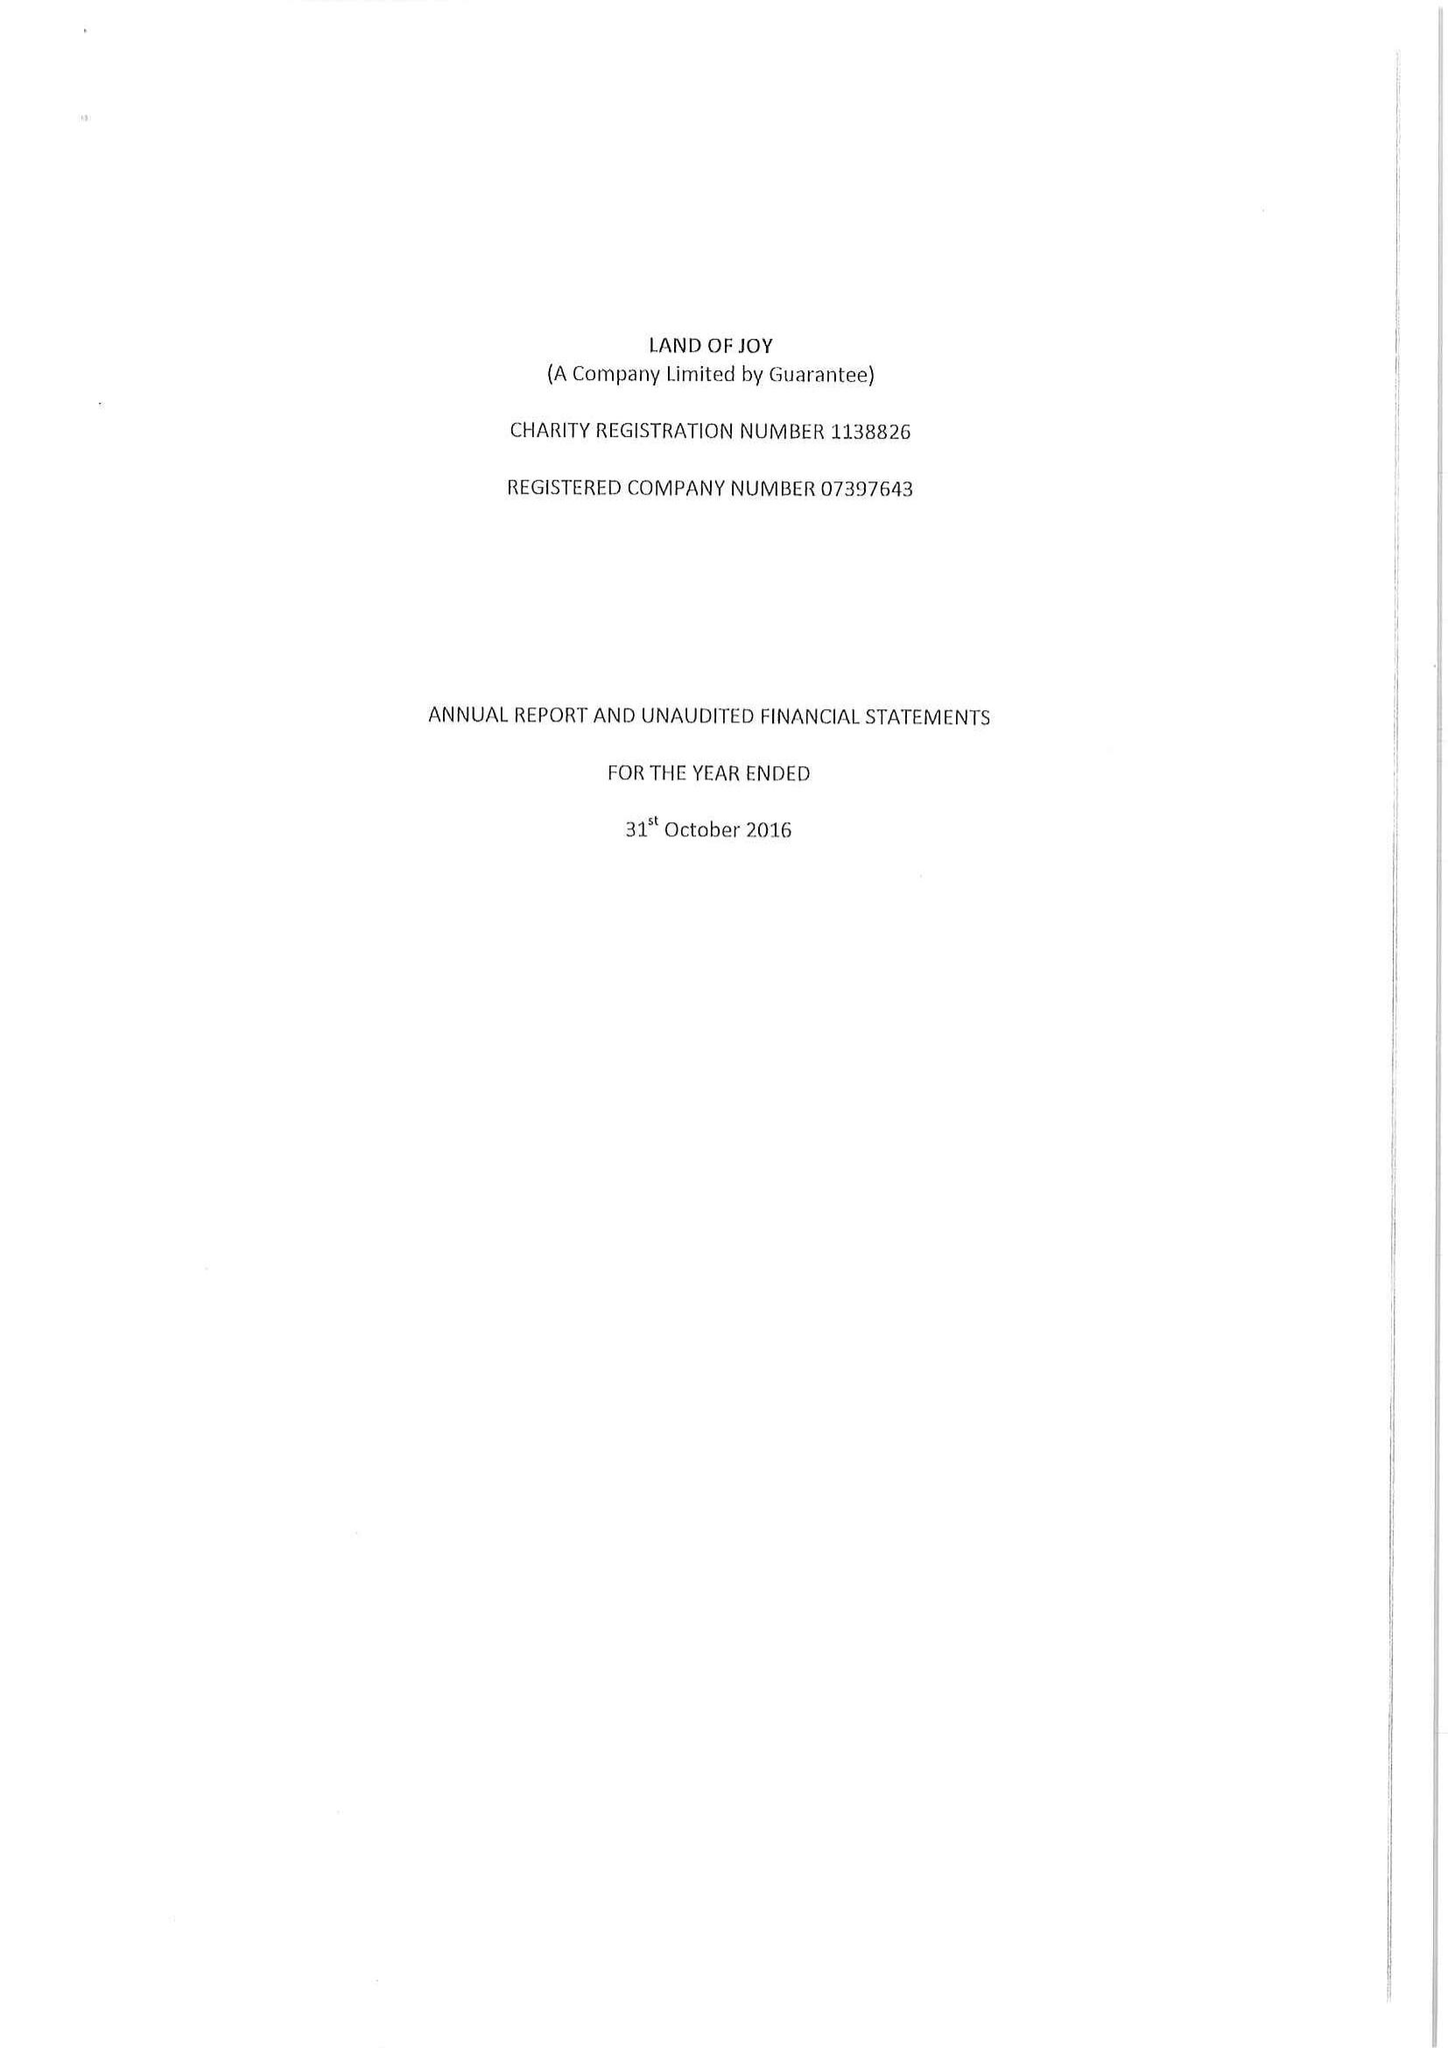What is the value for the spending_annually_in_british_pounds?
Answer the question using a single word or phrase. 100363.00 